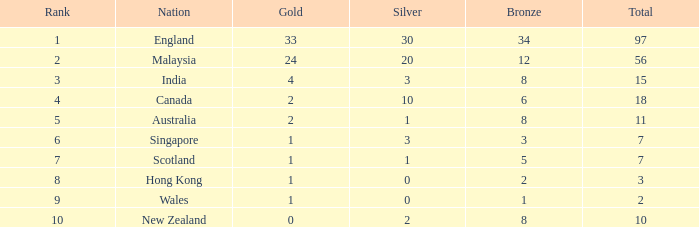What is the average silver medals a team that has 1 gold and more than 5 bronze has? None. Give me the full table as a dictionary. {'header': ['Rank', 'Nation', 'Gold', 'Silver', 'Bronze', 'Total'], 'rows': [['1', 'England', '33', '30', '34', '97'], ['2', 'Malaysia', '24', '20', '12', '56'], ['3', 'India', '4', '3', '8', '15'], ['4', 'Canada', '2', '10', '6', '18'], ['5', 'Australia', '2', '1', '8', '11'], ['6', 'Singapore', '1', '3', '3', '7'], ['7', 'Scotland', '1', '1', '5', '7'], ['8', 'Hong Kong', '1', '0', '2', '3'], ['9', 'Wales', '1', '0', '1', '2'], ['10', 'New Zealand', '0', '2', '8', '10']]} 